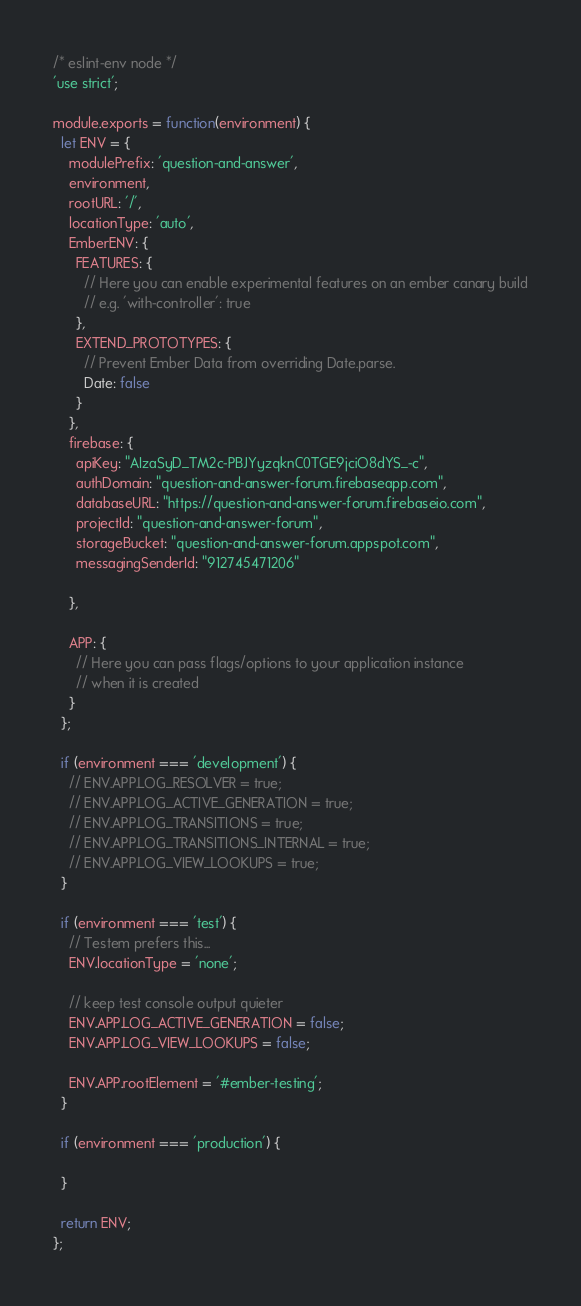Convert code to text. <code><loc_0><loc_0><loc_500><loc_500><_JavaScript_>/* eslint-env node */
'use strict';

module.exports = function(environment) {
  let ENV = {
    modulePrefix: 'question-and-answer',
    environment,
    rootURL: '/',
    locationType: 'auto',
    EmberENV: {
      FEATURES: {
        // Here you can enable experimental features on an ember canary build
        // e.g. 'with-controller': true
      },
      EXTEND_PROTOTYPES: {
        // Prevent Ember Data from overriding Date.parse.
        Date: false
      }
    },
    firebase: {
      apiKey: "AIzaSyD_TM2c-PBJYyzqknC0TGE9jciO8dYS_-c",
      authDomain: "question-and-answer-forum.firebaseapp.com",
      databaseURL: "https://question-and-answer-forum.firebaseio.com",
      projectId: "question-and-answer-forum",
      storageBucket: "question-and-answer-forum.appspot.com",
      messagingSenderId: "912745471206"

    },

    APP: {
      // Here you can pass flags/options to your application instance
      // when it is created
    }
  };

  if (environment === 'development') {
    // ENV.APP.LOG_RESOLVER = true;
    // ENV.APP.LOG_ACTIVE_GENERATION = true;
    // ENV.APP.LOG_TRANSITIONS = true;
    // ENV.APP.LOG_TRANSITIONS_INTERNAL = true;
    // ENV.APP.LOG_VIEW_LOOKUPS = true;
  }

  if (environment === 'test') {
    // Testem prefers this...
    ENV.locationType = 'none';

    // keep test console output quieter
    ENV.APP.LOG_ACTIVE_GENERATION = false;
    ENV.APP.LOG_VIEW_LOOKUPS = false;

    ENV.APP.rootElement = '#ember-testing';
  }

  if (environment === 'production') {

  }

  return ENV;
};
</code> 